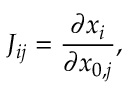Convert formula to latex. <formula><loc_0><loc_0><loc_500><loc_500>J _ { i j } = \frac { \partial x _ { i } } { \partial x _ { 0 , j } } ,</formula> 